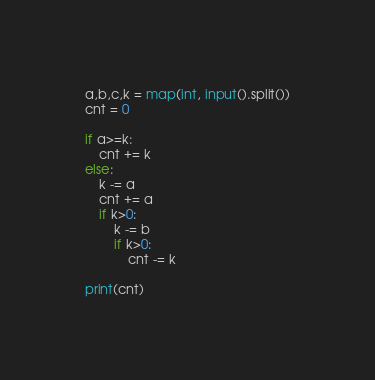Convert code to text. <code><loc_0><loc_0><loc_500><loc_500><_Python_>a,b,c,k = map(int, input().split())
cnt = 0

if a>=k:
    cnt += k
else:
    k -= a
    cnt += a
    if k>0:
        k -= b
        if k>0:
            cnt -= k

print(cnt)</code> 